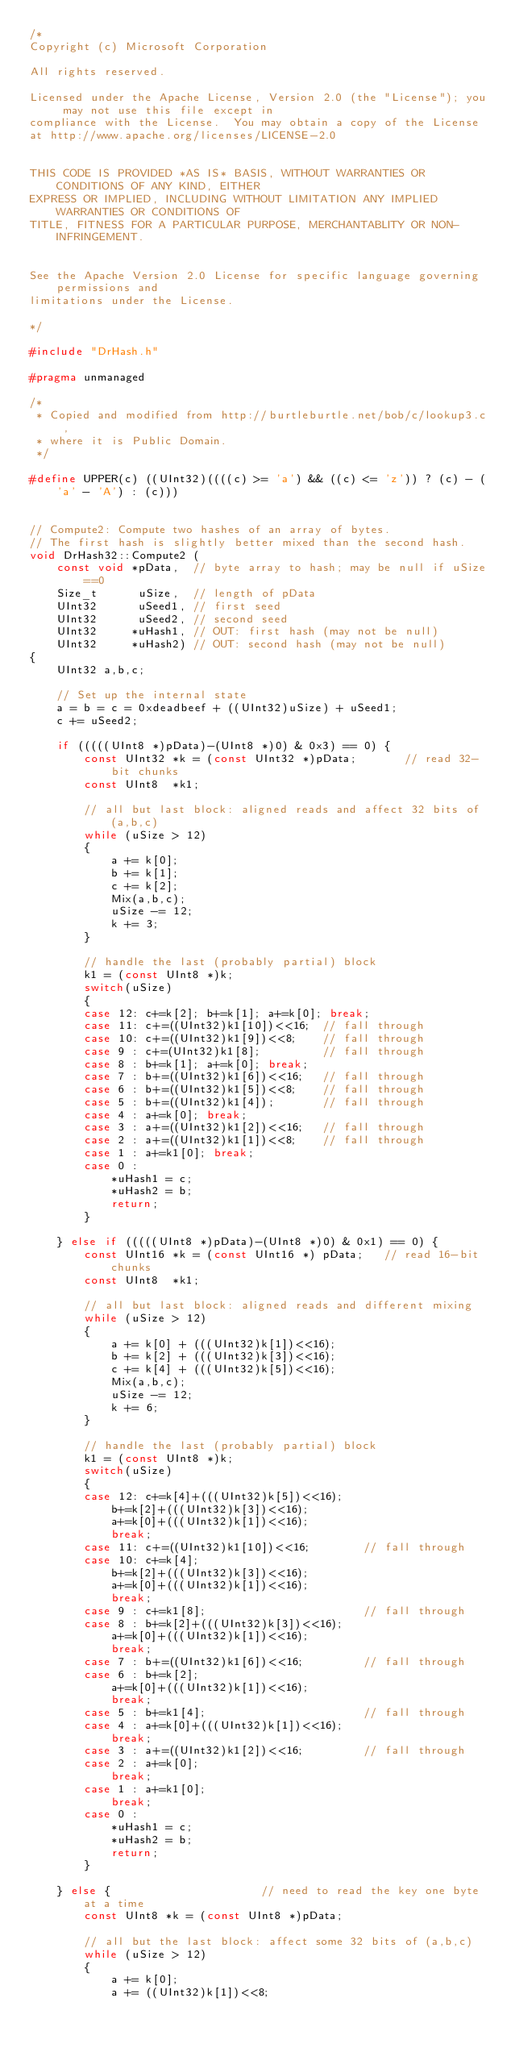Convert code to text. <code><loc_0><loc_0><loc_500><loc_500><_C++_>/*
Copyright (c) Microsoft Corporation

All rights reserved.

Licensed under the Apache License, Version 2.0 (the "License"); you may not use this file except in 
compliance with the License.  You may obtain a copy of the License 
at http://www.apache.org/licenses/LICENSE-2.0   


THIS CODE IS PROVIDED *AS IS* BASIS, WITHOUT WARRANTIES OR CONDITIONS OF ANY KIND, EITHER 
EXPRESS OR IMPLIED, INCLUDING WITHOUT LIMITATION ANY IMPLIED WARRANTIES OR CONDITIONS OF 
TITLE, FITNESS FOR A PARTICULAR PURPOSE, MERCHANTABLITY OR NON-INFRINGEMENT.  


See the Apache Version 2.0 License for specific language governing permissions and 
limitations under the License. 

*/

#include "DrHash.h"

#pragma unmanaged

/*
 * Copied and modified from http://burtleburtle.net/bob/c/lookup3.c,
 * where it is Public Domain.
 */

#define UPPER(c) ((UInt32)((((c) >= 'a') && ((c) <= 'z')) ? (c) - ('a' - 'A') : (c)))


// Compute2: Compute two hashes of an array of bytes.
// The first hash is slightly better mixed than the second hash.
void DrHash32::Compute2 (
    const void *pData,  // byte array to hash; may be null if uSize==0
    Size_t      uSize,  // length of pData
    UInt32      uSeed1, // first seed
    UInt32      uSeed2, // second seed
    UInt32     *uHash1, // OUT: first hash (may not be null)
    UInt32     *uHash2) // OUT: second hash (may not be null)
{
    UInt32 a,b,c;

    // Set up the internal state
    a = b = c = 0xdeadbeef + ((UInt32)uSize) + uSeed1;
    c += uSeed2;

    if (((((UInt8 *)pData)-(UInt8 *)0) & 0x3) == 0) {
        const UInt32 *k = (const UInt32 *)pData;       // read 32-bit chunks
        const UInt8  *k1;

        // all but last block: aligned reads and affect 32 bits of (a,b,c)
        while (uSize > 12)
        {
            a += k[0];
            b += k[1];
            c += k[2];
            Mix(a,b,c);
            uSize -= 12;
            k += 3;
        }

        // handle the last (probably partial) block
        k1 = (const UInt8 *)k;
        switch(uSize)
        {
        case 12: c+=k[2]; b+=k[1]; a+=k[0]; break;
        case 11: c+=((UInt32)k1[10])<<16;  // fall through
        case 10: c+=((UInt32)k1[9])<<8;    // fall through
        case 9 : c+=(UInt32)k1[8];         // fall through
        case 8 : b+=k[1]; a+=k[0]; break;
        case 7 : b+=((UInt32)k1[6])<<16;   // fall through
        case 6 : b+=((UInt32)k1[5])<<8;    // fall through
        case 5 : b+=((UInt32)k1[4]);       // fall through
        case 4 : a+=k[0]; break;
        case 3 : a+=((UInt32)k1[2])<<16;   // fall through
        case 2 : a+=((UInt32)k1[1])<<8;    // fall through
        case 1 : a+=k1[0]; break;
        case 0 : 
            *uHash1 = c;
            *uHash2 = b;
            return;
        }

    } else if (((((UInt8 *)pData)-(UInt8 *)0) & 0x1) == 0) {
        const UInt16 *k = (const UInt16 *) pData;   // read 16-bit chunks
        const UInt8  *k1;

        // all but last block: aligned reads and different mixing
        while (uSize > 12)
        {
            a += k[0] + (((UInt32)k[1])<<16);
            b += k[2] + (((UInt32)k[3])<<16);
            c += k[4] + (((UInt32)k[5])<<16);
            Mix(a,b,c);
            uSize -= 12;
            k += 6;
        }

        // handle the last (probably partial) block
        k1 = (const UInt8 *)k;
        switch(uSize)
        {
        case 12: c+=k[4]+(((UInt32)k[5])<<16);
            b+=k[2]+(((UInt32)k[3])<<16);
            a+=k[0]+(((UInt32)k[1])<<16);
            break;
        case 11: c+=((UInt32)k1[10])<<16;        // fall through
        case 10: c+=k[4];
            b+=k[2]+(((UInt32)k[3])<<16);
            a+=k[0]+(((UInt32)k[1])<<16);
            break;
        case 9 : c+=k1[8];                       // fall through
        case 8 : b+=k[2]+(((UInt32)k[3])<<16);
            a+=k[0]+(((UInt32)k[1])<<16);
            break;
        case 7 : b+=((UInt32)k1[6])<<16;         // fall through
        case 6 : b+=k[2];
            a+=k[0]+(((UInt32)k[1])<<16);
            break;
        case 5 : b+=k1[4];                       // fall through
        case 4 : a+=k[0]+(((UInt32)k[1])<<16);
            break;
        case 3 : a+=((UInt32)k1[2])<<16;         // fall through
        case 2 : a+=k[0];
            break;
        case 1 : a+=k1[0];
            break;
        case 0 :
            *uHash1 = c;
            *uHash2 = b;
            return;
        }

    } else {                      // need to read the key one byte at a time
        const UInt8 *k = (const UInt8 *)pData;

        // all but the last block: affect some 32 bits of (a,b,c)
        while (uSize > 12)
        {
            a += k[0];
            a += ((UInt32)k[1])<<8;</code> 